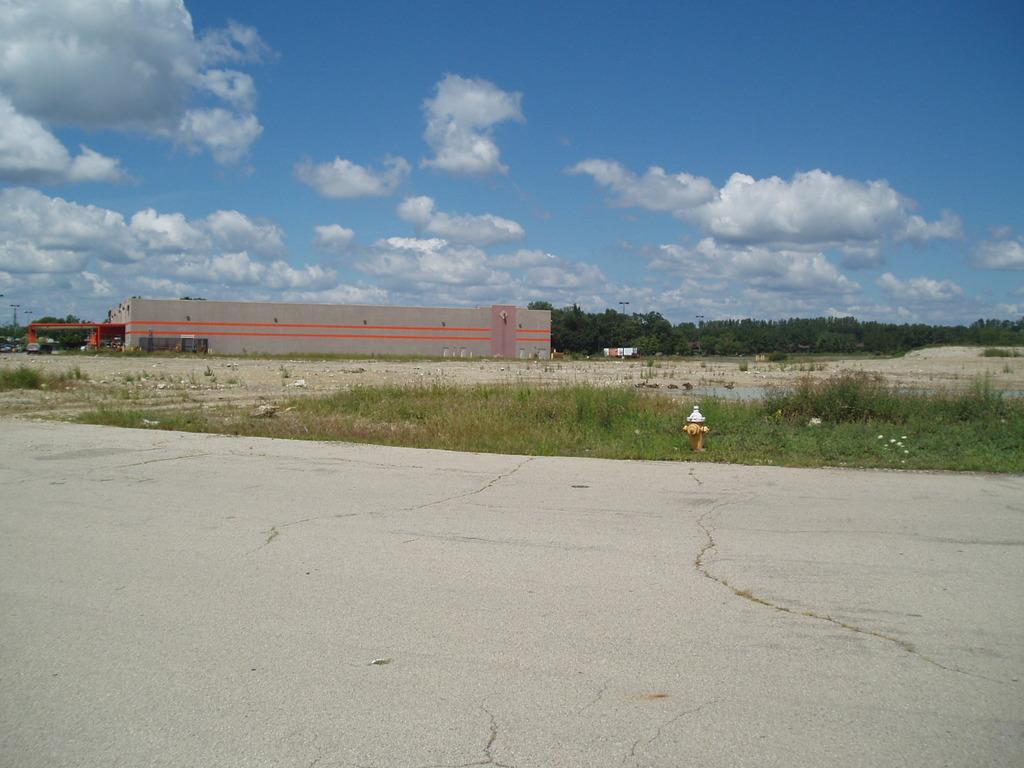Could you give a brief overview of what you see in this image? In this image we can see a road, building, grass, plants, trees, vehicles, sky and clouds. 